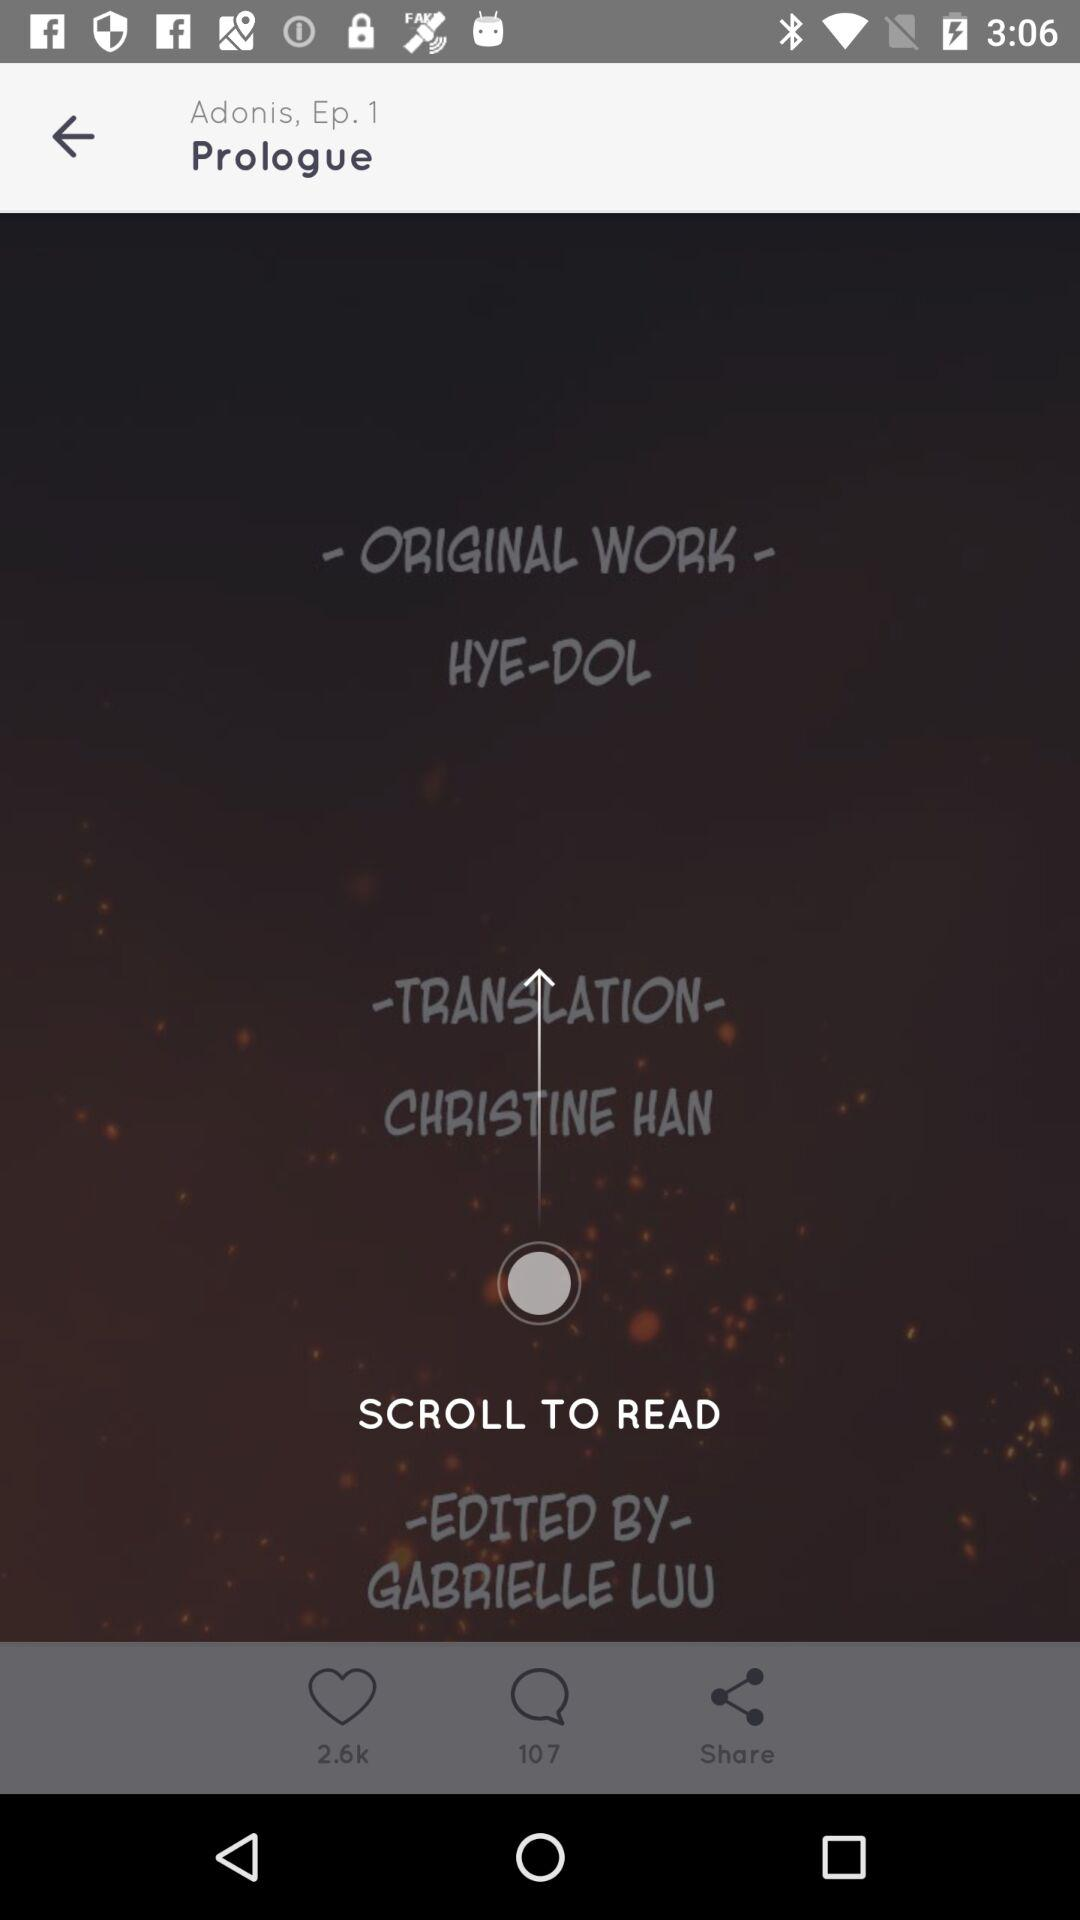How many authors are credited?
Answer the question using a single word or phrase. 3 